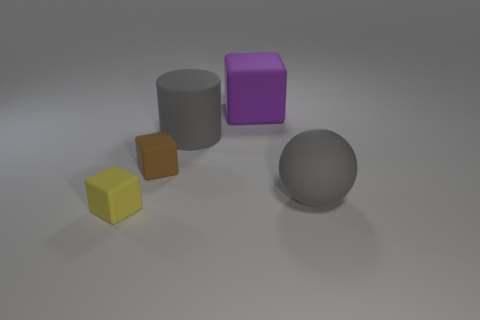Is the color of the large thing in front of the large cylinder the same as the large object that is on the left side of the purple thing?
Offer a terse response. Yes. What is the shape of the big gray thing to the right of the block behind the gray rubber object behind the tiny brown cube?
Your answer should be compact. Sphere. There is a gray object that is the same size as the gray rubber sphere; what is its shape?
Offer a very short reply. Cylinder. What number of matte things are behind the gray matte cylinder that is to the right of the matte block in front of the small brown matte thing?
Your response must be concise. 1. Are there more tiny yellow matte objects right of the large purple cube than large spheres on the left side of the yellow rubber object?
Make the answer very short. No. What number of gray objects are the same shape as the big purple rubber thing?
Keep it short and to the point. 0. How many things are large gray rubber objects that are right of the purple object or gray things in front of the large gray cylinder?
Your answer should be very brief. 1. What is the material of the large gray object that is behind the gray rubber thing that is on the right side of the large block that is behind the big rubber sphere?
Offer a terse response. Rubber. Does the matte sphere in front of the cylinder have the same color as the large cylinder?
Give a very brief answer. Yes. There is a big object that is both behind the big sphere and right of the big gray matte cylinder; what is its material?
Offer a terse response. Rubber. 